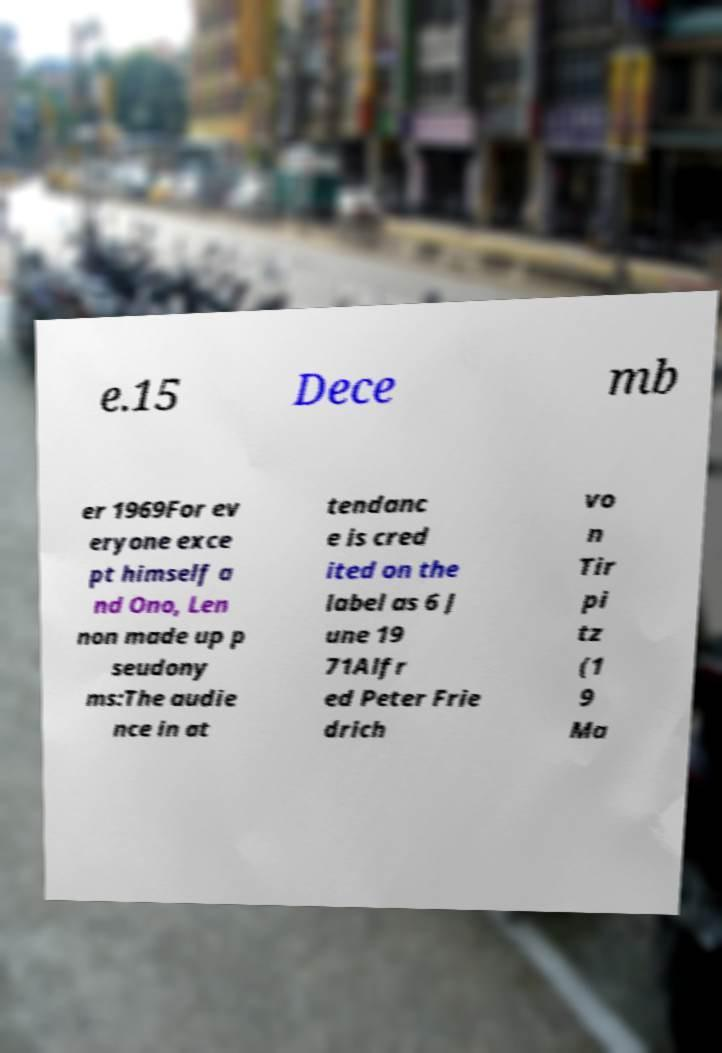Please identify and transcribe the text found in this image. e.15 Dece mb er 1969For ev eryone exce pt himself a nd Ono, Len non made up p seudony ms:The audie nce in at tendanc e is cred ited on the label as 6 J une 19 71Alfr ed Peter Frie drich vo n Tir pi tz (1 9 Ma 